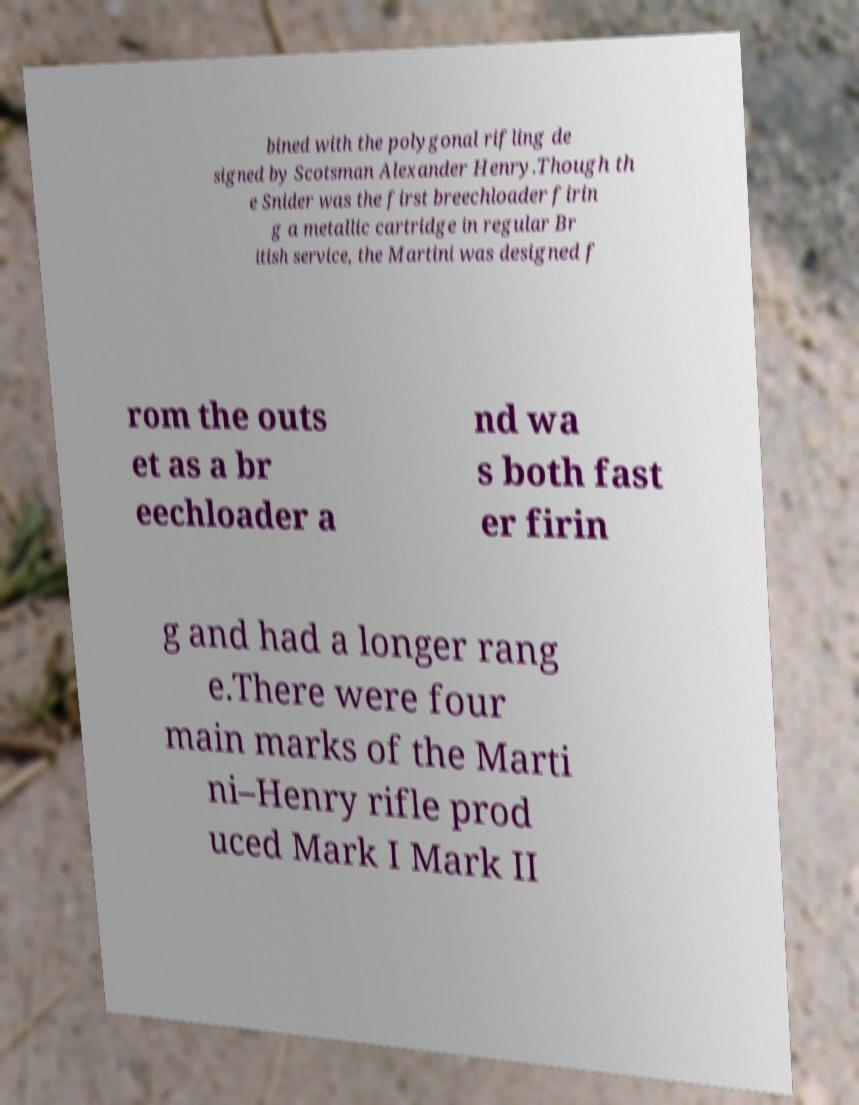Can you accurately transcribe the text from the provided image for me? bined with the polygonal rifling de signed by Scotsman Alexander Henry.Though th e Snider was the first breechloader firin g a metallic cartridge in regular Br itish service, the Martini was designed f rom the outs et as a br eechloader a nd wa s both fast er firin g and had a longer rang e.There were four main marks of the Marti ni–Henry rifle prod uced Mark I Mark II 